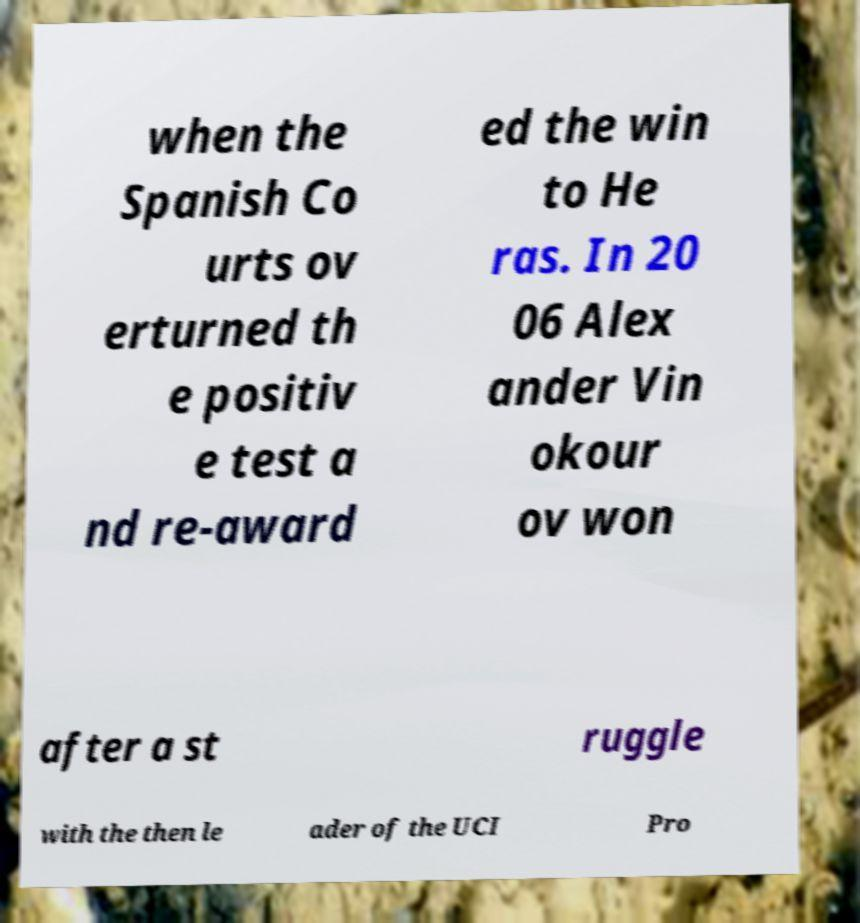For documentation purposes, I need the text within this image transcribed. Could you provide that? when the Spanish Co urts ov erturned th e positiv e test a nd re-award ed the win to He ras. In 20 06 Alex ander Vin okour ov won after a st ruggle with the then le ader of the UCI Pro 